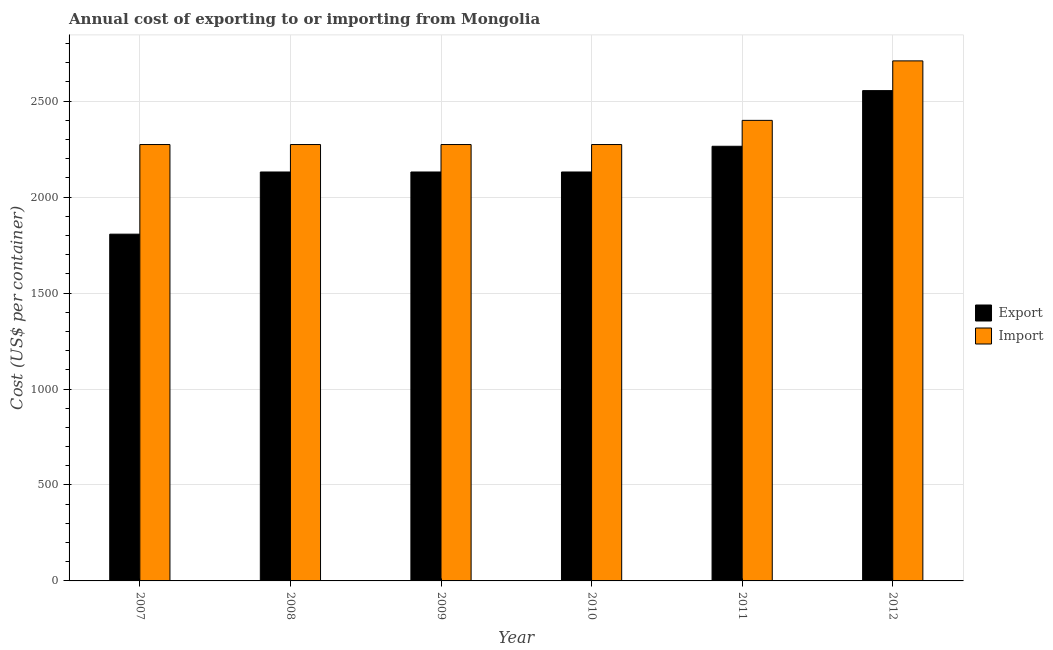How many groups of bars are there?
Keep it short and to the point. 6. Are the number of bars per tick equal to the number of legend labels?
Give a very brief answer. Yes. How many bars are there on the 5th tick from the right?
Your response must be concise. 2. What is the label of the 1st group of bars from the left?
Keep it short and to the point. 2007. What is the import cost in 2010?
Provide a succinct answer. 2274. Across all years, what is the maximum export cost?
Ensure brevity in your answer.  2555. Across all years, what is the minimum import cost?
Make the answer very short. 2274. In which year was the import cost maximum?
Your response must be concise. 2012. In which year was the export cost minimum?
Your response must be concise. 2007. What is the total import cost in the graph?
Ensure brevity in your answer.  1.42e+04. What is the difference between the export cost in 2008 and that in 2009?
Your answer should be compact. 0. What is the average import cost per year?
Ensure brevity in your answer.  2367.67. In how many years, is the import cost greater than 900 US$?
Give a very brief answer. 6. What is the ratio of the export cost in 2007 to that in 2011?
Keep it short and to the point. 0.8. Is the import cost in 2008 less than that in 2011?
Your response must be concise. Yes. What is the difference between the highest and the second highest import cost?
Provide a short and direct response. 310. What is the difference between the highest and the lowest import cost?
Offer a very short reply. 436. In how many years, is the export cost greater than the average export cost taken over all years?
Provide a short and direct response. 2. Is the sum of the import cost in 2008 and 2012 greater than the maximum export cost across all years?
Keep it short and to the point. Yes. What does the 2nd bar from the left in 2008 represents?
Your answer should be compact. Import. What does the 1st bar from the right in 2012 represents?
Offer a terse response. Import. Are all the bars in the graph horizontal?
Provide a short and direct response. No. What is the difference between two consecutive major ticks on the Y-axis?
Keep it short and to the point. 500. Does the graph contain grids?
Make the answer very short. Yes. How many legend labels are there?
Your answer should be compact. 2. What is the title of the graph?
Ensure brevity in your answer.  Annual cost of exporting to or importing from Mongolia. Does "US$" appear as one of the legend labels in the graph?
Ensure brevity in your answer.  No. What is the label or title of the X-axis?
Your response must be concise. Year. What is the label or title of the Y-axis?
Keep it short and to the point. Cost (US$ per container). What is the Cost (US$ per container) in Export in 2007?
Your response must be concise. 1807. What is the Cost (US$ per container) of Import in 2007?
Your response must be concise. 2274. What is the Cost (US$ per container) of Export in 2008?
Provide a short and direct response. 2131. What is the Cost (US$ per container) of Import in 2008?
Your response must be concise. 2274. What is the Cost (US$ per container) in Export in 2009?
Make the answer very short. 2131. What is the Cost (US$ per container) in Import in 2009?
Your response must be concise. 2274. What is the Cost (US$ per container) in Export in 2010?
Make the answer very short. 2131. What is the Cost (US$ per container) in Import in 2010?
Your answer should be compact. 2274. What is the Cost (US$ per container) of Export in 2011?
Your response must be concise. 2265. What is the Cost (US$ per container) in Import in 2011?
Give a very brief answer. 2400. What is the Cost (US$ per container) of Export in 2012?
Provide a succinct answer. 2555. What is the Cost (US$ per container) of Import in 2012?
Ensure brevity in your answer.  2710. Across all years, what is the maximum Cost (US$ per container) in Export?
Ensure brevity in your answer.  2555. Across all years, what is the maximum Cost (US$ per container) of Import?
Ensure brevity in your answer.  2710. Across all years, what is the minimum Cost (US$ per container) in Export?
Provide a short and direct response. 1807. Across all years, what is the minimum Cost (US$ per container) in Import?
Keep it short and to the point. 2274. What is the total Cost (US$ per container) of Export in the graph?
Make the answer very short. 1.30e+04. What is the total Cost (US$ per container) in Import in the graph?
Offer a terse response. 1.42e+04. What is the difference between the Cost (US$ per container) in Export in 2007 and that in 2008?
Make the answer very short. -324. What is the difference between the Cost (US$ per container) in Import in 2007 and that in 2008?
Ensure brevity in your answer.  0. What is the difference between the Cost (US$ per container) of Export in 2007 and that in 2009?
Your answer should be compact. -324. What is the difference between the Cost (US$ per container) of Export in 2007 and that in 2010?
Keep it short and to the point. -324. What is the difference between the Cost (US$ per container) of Import in 2007 and that in 2010?
Give a very brief answer. 0. What is the difference between the Cost (US$ per container) in Export in 2007 and that in 2011?
Provide a short and direct response. -458. What is the difference between the Cost (US$ per container) in Import in 2007 and that in 2011?
Keep it short and to the point. -126. What is the difference between the Cost (US$ per container) in Export in 2007 and that in 2012?
Provide a short and direct response. -748. What is the difference between the Cost (US$ per container) of Import in 2007 and that in 2012?
Provide a short and direct response. -436. What is the difference between the Cost (US$ per container) in Export in 2008 and that in 2009?
Ensure brevity in your answer.  0. What is the difference between the Cost (US$ per container) in Import in 2008 and that in 2009?
Your answer should be compact. 0. What is the difference between the Cost (US$ per container) of Export in 2008 and that in 2011?
Keep it short and to the point. -134. What is the difference between the Cost (US$ per container) of Import in 2008 and that in 2011?
Your answer should be very brief. -126. What is the difference between the Cost (US$ per container) in Export in 2008 and that in 2012?
Your response must be concise. -424. What is the difference between the Cost (US$ per container) in Import in 2008 and that in 2012?
Give a very brief answer. -436. What is the difference between the Cost (US$ per container) in Import in 2009 and that in 2010?
Offer a very short reply. 0. What is the difference between the Cost (US$ per container) in Export in 2009 and that in 2011?
Provide a short and direct response. -134. What is the difference between the Cost (US$ per container) of Import in 2009 and that in 2011?
Your answer should be compact. -126. What is the difference between the Cost (US$ per container) of Export in 2009 and that in 2012?
Offer a very short reply. -424. What is the difference between the Cost (US$ per container) of Import in 2009 and that in 2012?
Make the answer very short. -436. What is the difference between the Cost (US$ per container) of Export in 2010 and that in 2011?
Your response must be concise. -134. What is the difference between the Cost (US$ per container) in Import in 2010 and that in 2011?
Provide a succinct answer. -126. What is the difference between the Cost (US$ per container) in Export in 2010 and that in 2012?
Keep it short and to the point. -424. What is the difference between the Cost (US$ per container) in Import in 2010 and that in 2012?
Keep it short and to the point. -436. What is the difference between the Cost (US$ per container) in Export in 2011 and that in 2012?
Make the answer very short. -290. What is the difference between the Cost (US$ per container) in Import in 2011 and that in 2012?
Offer a terse response. -310. What is the difference between the Cost (US$ per container) in Export in 2007 and the Cost (US$ per container) in Import in 2008?
Your response must be concise. -467. What is the difference between the Cost (US$ per container) in Export in 2007 and the Cost (US$ per container) in Import in 2009?
Provide a succinct answer. -467. What is the difference between the Cost (US$ per container) of Export in 2007 and the Cost (US$ per container) of Import in 2010?
Your answer should be compact. -467. What is the difference between the Cost (US$ per container) of Export in 2007 and the Cost (US$ per container) of Import in 2011?
Make the answer very short. -593. What is the difference between the Cost (US$ per container) of Export in 2007 and the Cost (US$ per container) of Import in 2012?
Make the answer very short. -903. What is the difference between the Cost (US$ per container) of Export in 2008 and the Cost (US$ per container) of Import in 2009?
Ensure brevity in your answer.  -143. What is the difference between the Cost (US$ per container) in Export in 2008 and the Cost (US$ per container) in Import in 2010?
Keep it short and to the point. -143. What is the difference between the Cost (US$ per container) in Export in 2008 and the Cost (US$ per container) in Import in 2011?
Make the answer very short. -269. What is the difference between the Cost (US$ per container) of Export in 2008 and the Cost (US$ per container) of Import in 2012?
Your response must be concise. -579. What is the difference between the Cost (US$ per container) in Export in 2009 and the Cost (US$ per container) in Import in 2010?
Provide a short and direct response. -143. What is the difference between the Cost (US$ per container) of Export in 2009 and the Cost (US$ per container) of Import in 2011?
Provide a succinct answer. -269. What is the difference between the Cost (US$ per container) of Export in 2009 and the Cost (US$ per container) of Import in 2012?
Ensure brevity in your answer.  -579. What is the difference between the Cost (US$ per container) in Export in 2010 and the Cost (US$ per container) in Import in 2011?
Offer a very short reply. -269. What is the difference between the Cost (US$ per container) in Export in 2010 and the Cost (US$ per container) in Import in 2012?
Offer a very short reply. -579. What is the difference between the Cost (US$ per container) in Export in 2011 and the Cost (US$ per container) in Import in 2012?
Your answer should be compact. -445. What is the average Cost (US$ per container) of Export per year?
Provide a short and direct response. 2170. What is the average Cost (US$ per container) of Import per year?
Give a very brief answer. 2367.67. In the year 2007, what is the difference between the Cost (US$ per container) of Export and Cost (US$ per container) of Import?
Provide a succinct answer. -467. In the year 2008, what is the difference between the Cost (US$ per container) of Export and Cost (US$ per container) of Import?
Ensure brevity in your answer.  -143. In the year 2009, what is the difference between the Cost (US$ per container) in Export and Cost (US$ per container) in Import?
Your response must be concise. -143. In the year 2010, what is the difference between the Cost (US$ per container) of Export and Cost (US$ per container) of Import?
Offer a very short reply. -143. In the year 2011, what is the difference between the Cost (US$ per container) of Export and Cost (US$ per container) of Import?
Offer a very short reply. -135. In the year 2012, what is the difference between the Cost (US$ per container) of Export and Cost (US$ per container) of Import?
Keep it short and to the point. -155. What is the ratio of the Cost (US$ per container) of Export in 2007 to that in 2008?
Provide a short and direct response. 0.85. What is the ratio of the Cost (US$ per container) in Export in 2007 to that in 2009?
Ensure brevity in your answer.  0.85. What is the ratio of the Cost (US$ per container) in Export in 2007 to that in 2010?
Your answer should be very brief. 0.85. What is the ratio of the Cost (US$ per container) in Export in 2007 to that in 2011?
Offer a very short reply. 0.8. What is the ratio of the Cost (US$ per container) in Import in 2007 to that in 2011?
Ensure brevity in your answer.  0.95. What is the ratio of the Cost (US$ per container) in Export in 2007 to that in 2012?
Ensure brevity in your answer.  0.71. What is the ratio of the Cost (US$ per container) of Import in 2007 to that in 2012?
Offer a very short reply. 0.84. What is the ratio of the Cost (US$ per container) in Export in 2008 to that in 2009?
Offer a terse response. 1. What is the ratio of the Cost (US$ per container) in Import in 2008 to that in 2009?
Your answer should be compact. 1. What is the ratio of the Cost (US$ per container) of Export in 2008 to that in 2010?
Provide a short and direct response. 1. What is the ratio of the Cost (US$ per container) in Export in 2008 to that in 2011?
Ensure brevity in your answer.  0.94. What is the ratio of the Cost (US$ per container) in Import in 2008 to that in 2011?
Keep it short and to the point. 0.95. What is the ratio of the Cost (US$ per container) in Export in 2008 to that in 2012?
Make the answer very short. 0.83. What is the ratio of the Cost (US$ per container) in Import in 2008 to that in 2012?
Provide a short and direct response. 0.84. What is the ratio of the Cost (US$ per container) in Export in 2009 to that in 2010?
Your response must be concise. 1. What is the ratio of the Cost (US$ per container) in Import in 2009 to that in 2010?
Provide a succinct answer. 1. What is the ratio of the Cost (US$ per container) in Export in 2009 to that in 2011?
Your answer should be compact. 0.94. What is the ratio of the Cost (US$ per container) of Import in 2009 to that in 2011?
Make the answer very short. 0.95. What is the ratio of the Cost (US$ per container) in Export in 2009 to that in 2012?
Your answer should be compact. 0.83. What is the ratio of the Cost (US$ per container) of Import in 2009 to that in 2012?
Provide a succinct answer. 0.84. What is the ratio of the Cost (US$ per container) in Export in 2010 to that in 2011?
Your response must be concise. 0.94. What is the ratio of the Cost (US$ per container) in Import in 2010 to that in 2011?
Make the answer very short. 0.95. What is the ratio of the Cost (US$ per container) of Export in 2010 to that in 2012?
Provide a succinct answer. 0.83. What is the ratio of the Cost (US$ per container) in Import in 2010 to that in 2012?
Keep it short and to the point. 0.84. What is the ratio of the Cost (US$ per container) in Export in 2011 to that in 2012?
Provide a short and direct response. 0.89. What is the ratio of the Cost (US$ per container) in Import in 2011 to that in 2012?
Give a very brief answer. 0.89. What is the difference between the highest and the second highest Cost (US$ per container) of Export?
Your response must be concise. 290. What is the difference between the highest and the second highest Cost (US$ per container) of Import?
Your answer should be very brief. 310. What is the difference between the highest and the lowest Cost (US$ per container) in Export?
Keep it short and to the point. 748. What is the difference between the highest and the lowest Cost (US$ per container) in Import?
Your response must be concise. 436. 